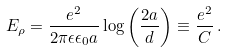<formula> <loc_0><loc_0><loc_500><loc_500>E _ { \rho } = \frac { e ^ { 2 } } { 2 \pi \epsilon \epsilon _ { 0 } a } \log \left ( \frac { 2 a } { d } \right ) \equiv \frac { e ^ { 2 } } { C } \, .</formula> 